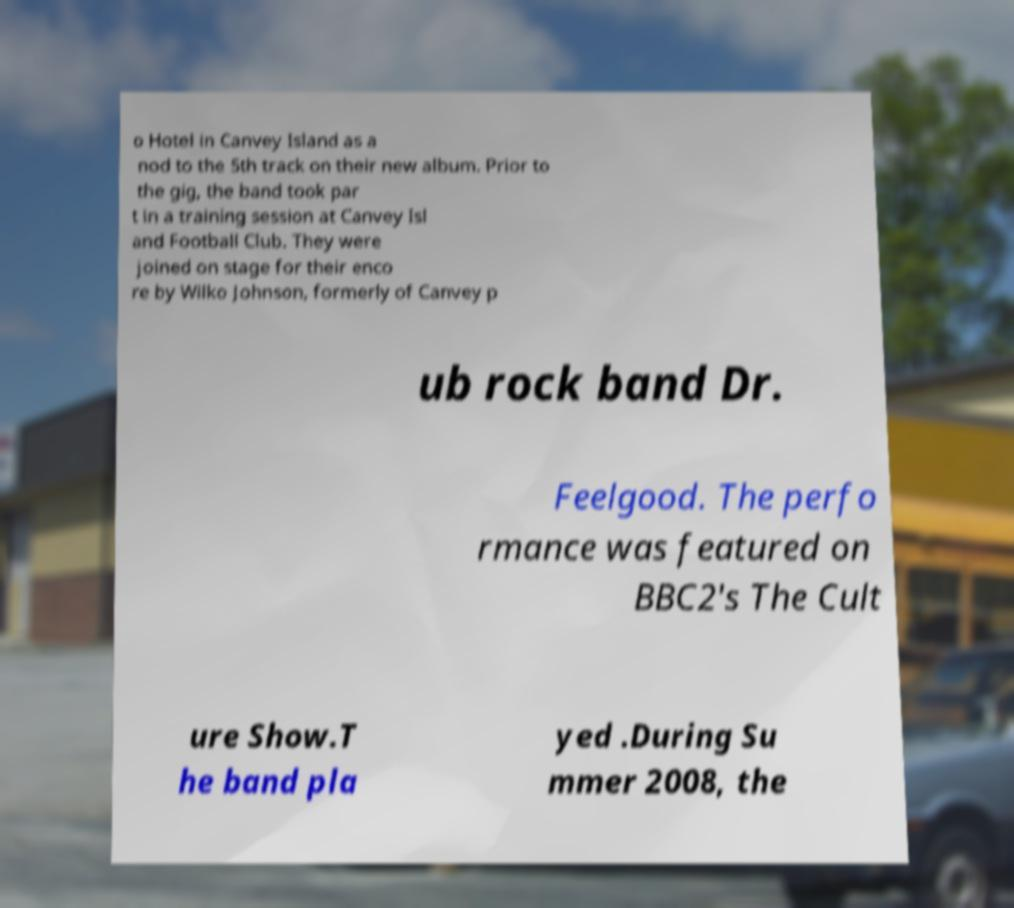Could you extract and type out the text from this image? o Hotel in Canvey Island as a nod to the 5th track on their new album. Prior to the gig, the band took par t in a training session at Canvey Isl and Football Club. They were joined on stage for their enco re by Wilko Johnson, formerly of Canvey p ub rock band Dr. Feelgood. The perfo rmance was featured on BBC2's The Cult ure Show.T he band pla yed .During Su mmer 2008, the 